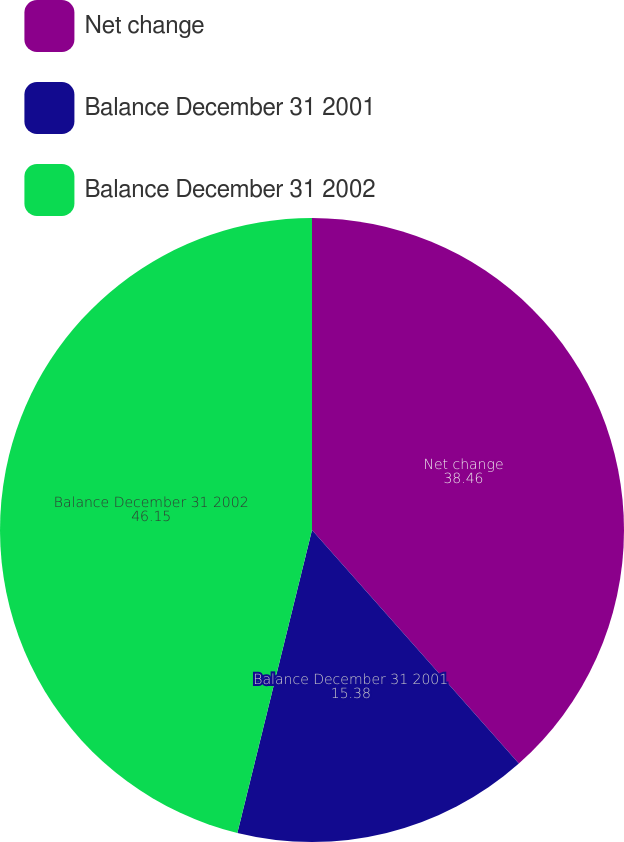<chart> <loc_0><loc_0><loc_500><loc_500><pie_chart><fcel>Net change<fcel>Balance December 31 2001<fcel>Balance December 31 2002<nl><fcel>38.46%<fcel>15.38%<fcel>46.15%<nl></chart> 